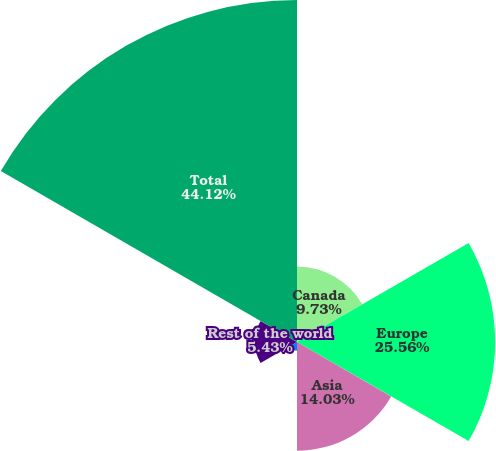Convert chart to OTSL. <chart><loc_0><loc_0><loc_500><loc_500><pie_chart><fcel>Canada<fcel>Europe<fcel>Asia<fcel>Middle East<fcel>Rest of the world<fcel>Total<nl><fcel>9.73%<fcel>25.56%<fcel>14.03%<fcel>1.13%<fcel>5.43%<fcel>44.11%<nl></chart> 